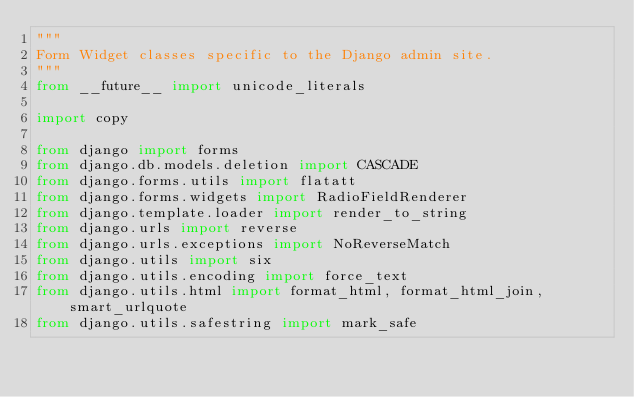Convert code to text. <code><loc_0><loc_0><loc_500><loc_500><_Python_>"""
Form Widget classes specific to the Django admin site.
"""
from __future__ import unicode_literals

import copy

from django import forms
from django.db.models.deletion import CASCADE
from django.forms.utils import flatatt
from django.forms.widgets import RadioFieldRenderer
from django.template.loader import render_to_string
from django.urls import reverse
from django.urls.exceptions import NoReverseMatch
from django.utils import six
from django.utils.encoding import force_text
from django.utils.html import format_html, format_html_join, smart_urlquote
from django.utils.safestring import mark_safe</code> 